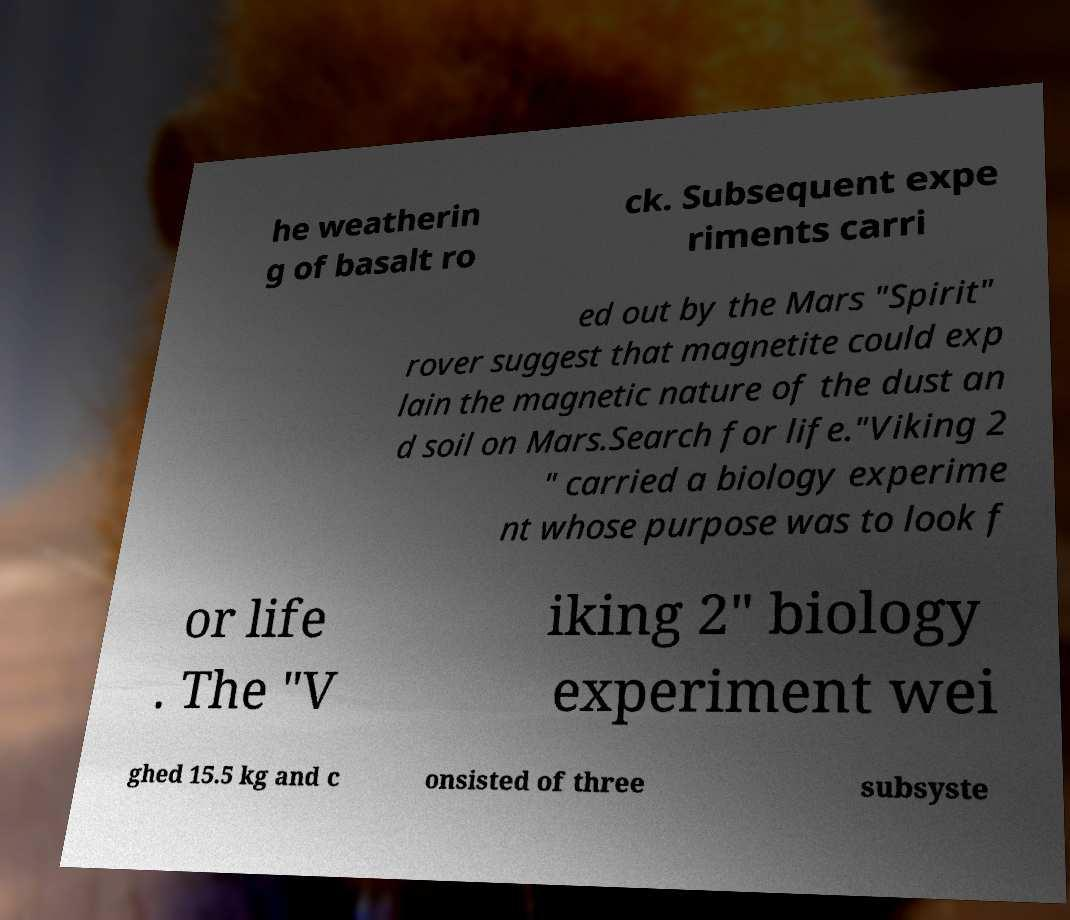I need the written content from this picture converted into text. Can you do that? he weatherin g of basalt ro ck. Subsequent expe riments carri ed out by the Mars "Spirit" rover suggest that magnetite could exp lain the magnetic nature of the dust an d soil on Mars.Search for life."Viking 2 " carried a biology experime nt whose purpose was to look f or life . The "V iking 2" biology experiment wei ghed 15.5 kg and c onsisted of three subsyste 